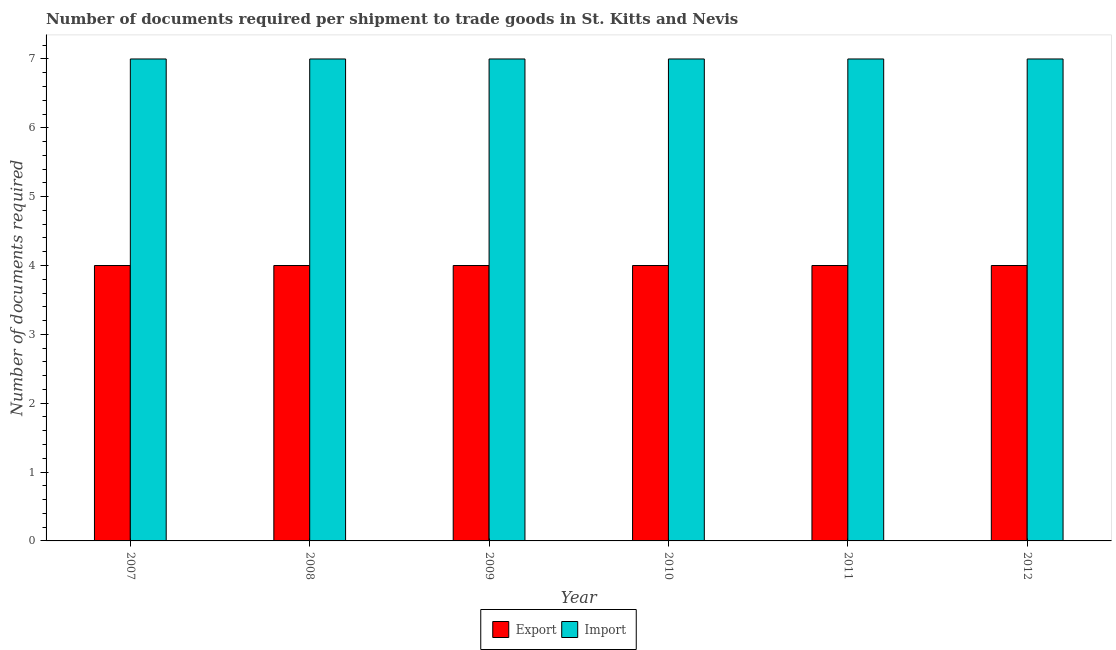How many different coloured bars are there?
Offer a very short reply. 2. How many groups of bars are there?
Keep it short and to the point. 6. Are the number of bars on each tick of the X-axis equal?
Provide a succinct answer. Yes. How many bars are there on the 2nd tick from the left?
Give a very brief answer. 2. What is the label of the 2nd group of bars from the left?
Your response must be concise. 2008. In how many cases, is the number of bars for a given year not equal to the number of legend labels?
Offer a terse response. 0. What is the number of documents required to export goods in 2007?
Provide a short and direct response. 4. Across all years, what is the maximum number of documents required to import goods?
Provide a succinct answer. 7. Across all years, what is the minimum number of documents required to export goods?
Offer a very short reply. 4. What is the total number of documents required to export goods in the graph?
Provide a succinct answer. 24. What is the difference between the number of documents required to import goods in 2009 and that in 2010?
Your answer should be very brief. 0. What is the difference between the number of documents required to export goods in 2012 and the number of documents required to import goods in 2007?
Offer a very short reply. 0. In the year 2012, what is the difference between the number of documents required to export goods and number of documents required to import goods?
Offer a very short reply. 0. In how many years, is the number of documents required to export goods greater than 1.6?
Offer a terse response. 6. What is the difference between the highest and the second highest number of documents required to export goods?
Your answer should be compact. 0. Is the sum of the number of documents required to export goods in 2008 and 2009 greater than the maximum number of documents required to import goods across all years?
Give a very brief answer. Yes. What does the 2nd bar from the left in 2012 represents?
Your answer should be compact. Import. What does the 1st bar from the right in 2011 represents?
Your answer should be compact. Import. How many bars are there?
Keep it short and to the point. 12. Are all the bars in the graph horizontal?
Ensure brevity in your answer.  No. What is the difference between two consecutive major ticks on the Y-axis?
Your response must be concise. 1. Does the graph contain any zero values?
Your response must be concise. No. Where does the legend appear in the graph?
Ensure brevity in your answer.  Bottom center. How many legend labels are there?
Provide a succinct answer. 2. How are the legend labels stacked?
Your answer should be compact. Horizontal. What is the title of the graph?
Your response must be concise. Number of documents required per shipment to trade goods in St. Kitts and Nevis. What is the label or title of the X-axis?
Provide a short and direct response. Year. What is the label or title of the Y-axis?
Make the answer very short. Number of documents required. What is the Number of documents required of Export in 2008?
Keep it short and to the point. 4. What is the Number of documents required in Import in 2009?
Provide a succinct answer. 7. What is the Number of documents required in Import in 2010?
Offer a terse response. 7. What is the Number of documents required in Export in 2012?
Your response must be concise. 4. Across all years, what is the maximum Number of documents required in Export?
Provide a succinct answer. 4. Across all years, what is the maximum Number of documents required of Import?
Keep it short and to the point. 7. Across all years, what is the minimum Number of documents required of Import?
Your answer should be compact. 7. What is the total Number of documents required in Export in the graph?
Ensure brevity in your answer.  24. What is the total Number of documents required in Import in the graph?
Offer a terse response. 42. What is the difference between the Number of documents required of Export in 2007 and that in 2008?
Ensure brevity in your answer.  0. What is the difference between the Number of documents required of Import in 2007 and that in 2008?
Ensure brevity in your answer.  0. What is the difference between the Number of documents required in Export in 2007 and that in 2010?
Offer a very short reply. 0. What is the difference between the Number of documents required of Import in 2008 and that in 2010?
Keep it short and to the point. 0. What is the difference between the Number of documents required of Export in 2008 and that in 2011?
Provide a succinct answer. 0. What is the difference between the Number of documents required of Export in 2009 and that in 2010?
Ensure brevity in your answer.  0. What is the difference between the Number of documents required in Import in 2009 and that in 2010?
Keep it short and to the point. 0. What is the difference between the Number of documents required of Export in 2009 and that in 2012?
Give a very brief answer. 0. What is the difference between the Number of documents required of Export in 2010 and that in 2011?
Keep it short and to the point. 0. What is the difference between the Number of documents required of Import in 2010 and that in 2011?
Keep it short and to the point. 0. What is the difference between the Number of documents required of Export in 2007 and the Number of documents required of Import in 2009?
Keep it short and to the point. -3. What is the difference between the Number of documents required in Export in 2007 and the Number of documents required in Import in 2010?
Give a very brief answer. -3. What is the difference between the Number of documents required of Export in 2007 and the Number of documents required of Import in 2011?
Ensure brevity in your answer.  -3. What is the difference between the Number of documents required in Export in 2007 and the Number of documents required in Import in 2012?
Your response must be concise. -3. What is the difference between the Number of documents required of Export in 2008 and the Number of documents required of Import in 2010?
Keep it short and to the point. -3. What is the difference between the Number of documents required in Export in 2008 and the Number of documents required in Import in 2011?
Your response must be concise. -3. What is the difference between the Number of documents required of Export in 2009 and the Number of documents required of Import in 2010?
Offer a very short reply. -3. What is the difference between the Number of documents required in Export in 2009 and the Number of documents required in Import in 2012?
Make the answer very short. -3. What is the difference between the Number of documents required of Export in 2010 and the Number of documents required of Import in 2012?
Your answer should be compact. -3. What is the difference between the Number of documents required in Export in 2011 and the Number of documents required in Import in 2012?
Provide a short and direct response. -3. What is the average Number of documents required of Export per year?
Your answer should be very brief. 4. What is the average Number of documents required of Import per year?
Your answer should be very brief. 7. In the year 2007, what is the difference between the Number of documents required in Export and Number of documents required in Import?
Offer a terse response. -3. In the year 2011, what is the difference between the Number of documents required in Export and Number of documents required in Import?
Offer a very short reply. -3. What is the ratio of the Number of documents required in Import in 2007 to that in 2008?
Make the answer very short. 1. What is the ratio of the Number of documents required of Export in 2007 to that in 2010?
Offer a terse response. 1. What is the ratio of the Number of documents required of Import in 2008 to that in 2010?
Keep it short and to the point. 1. What is the ratio of the Number of documents required in Export in 2008 to that in 2012?
Keep it short and to the point. 1. What is the ratio of the Number of documents required in Import in 2009 to that in 2010?
Provide a short and direct response. 1. What is the ratio of the Number of documents required of Export in 2009 to that in 2012?
Keep it short and to the point. 1. What is the ratio of the Number of documents required in Export in 2010 to that in 2011?
Ensure brevity in your answer.  1. What is the ratio of the Number of documents required in Export in 2010 to that in 2012?
Your response must be concise. 1. What is the ratio of the Number of documents required in Export in 2011 to that in 2012?
Keep it short and to the point. 1. What is the ratio of the Number of documents required in Import in 2011 to that in 2012?
Your answer should be compact. 1. What is the difference between the highest and the lowest Number of documents required of Export?
Keep it short and to the point. 0. 